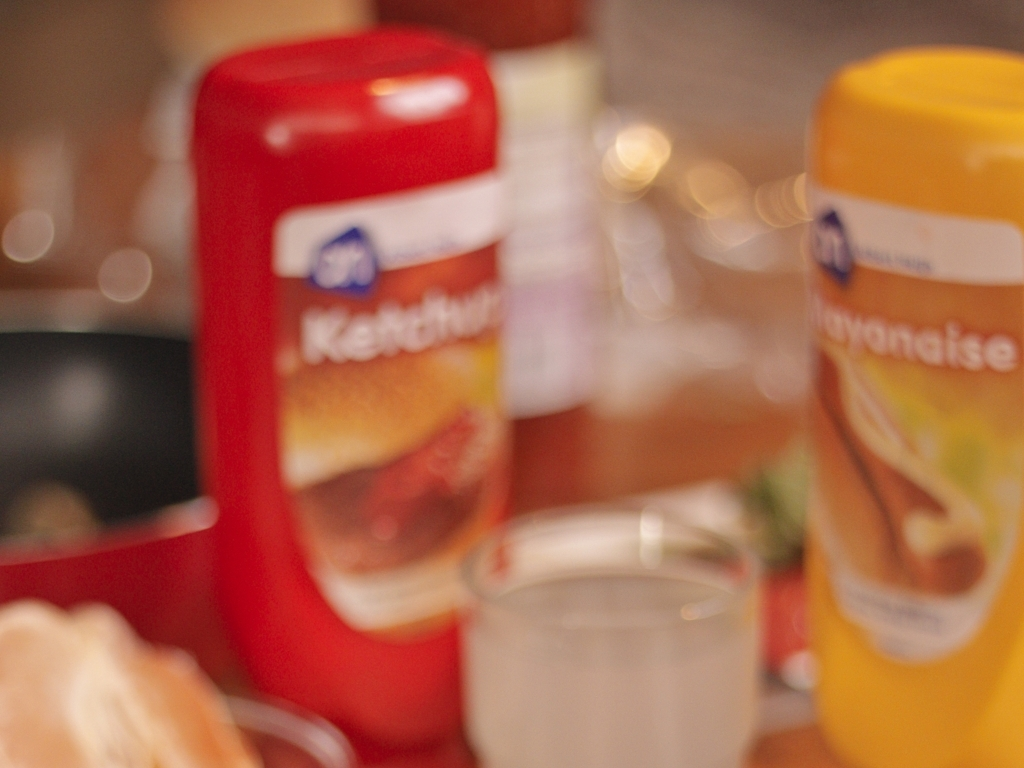Can you suggest how the image could be improved? Improving this image might involve using a narrower aperture to increase the depth of field and bring more of the scene into focus. Additionally, using a tripod or stabilizer could help prevent motion blur, and taking the photo with a high-quality lens would enhance overall sharpness. 